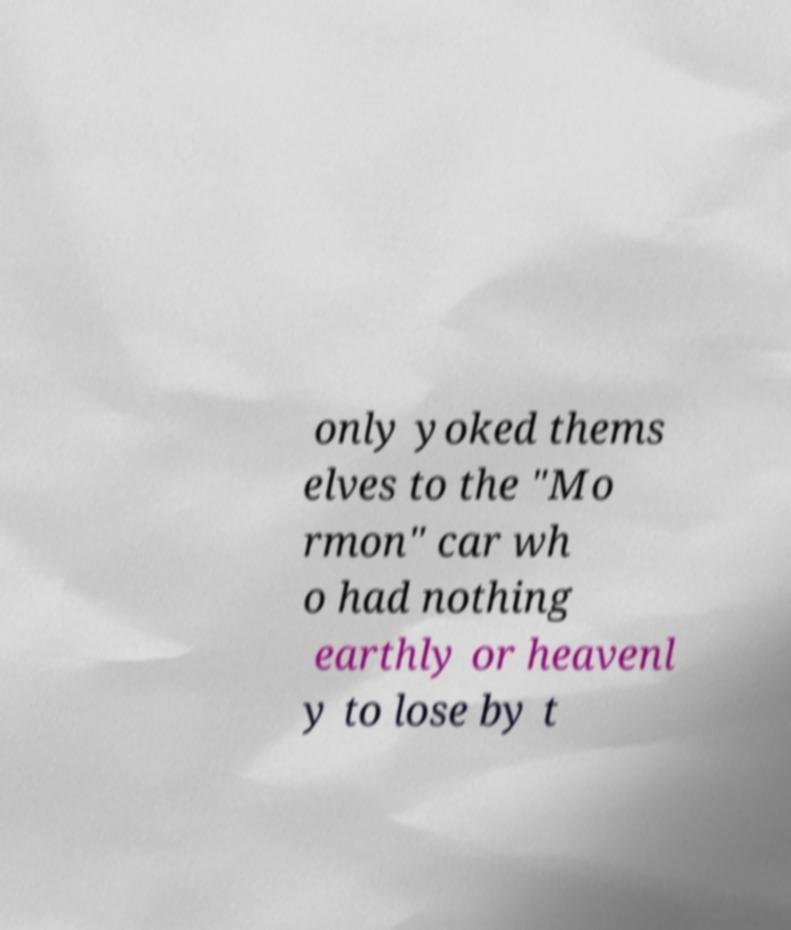Could you assist in decoding the text presented in this image and type it out clearly? only yoked thems elves to the "Mo rmon" car wh o had nothing earthly or heavenl y to lose by t 